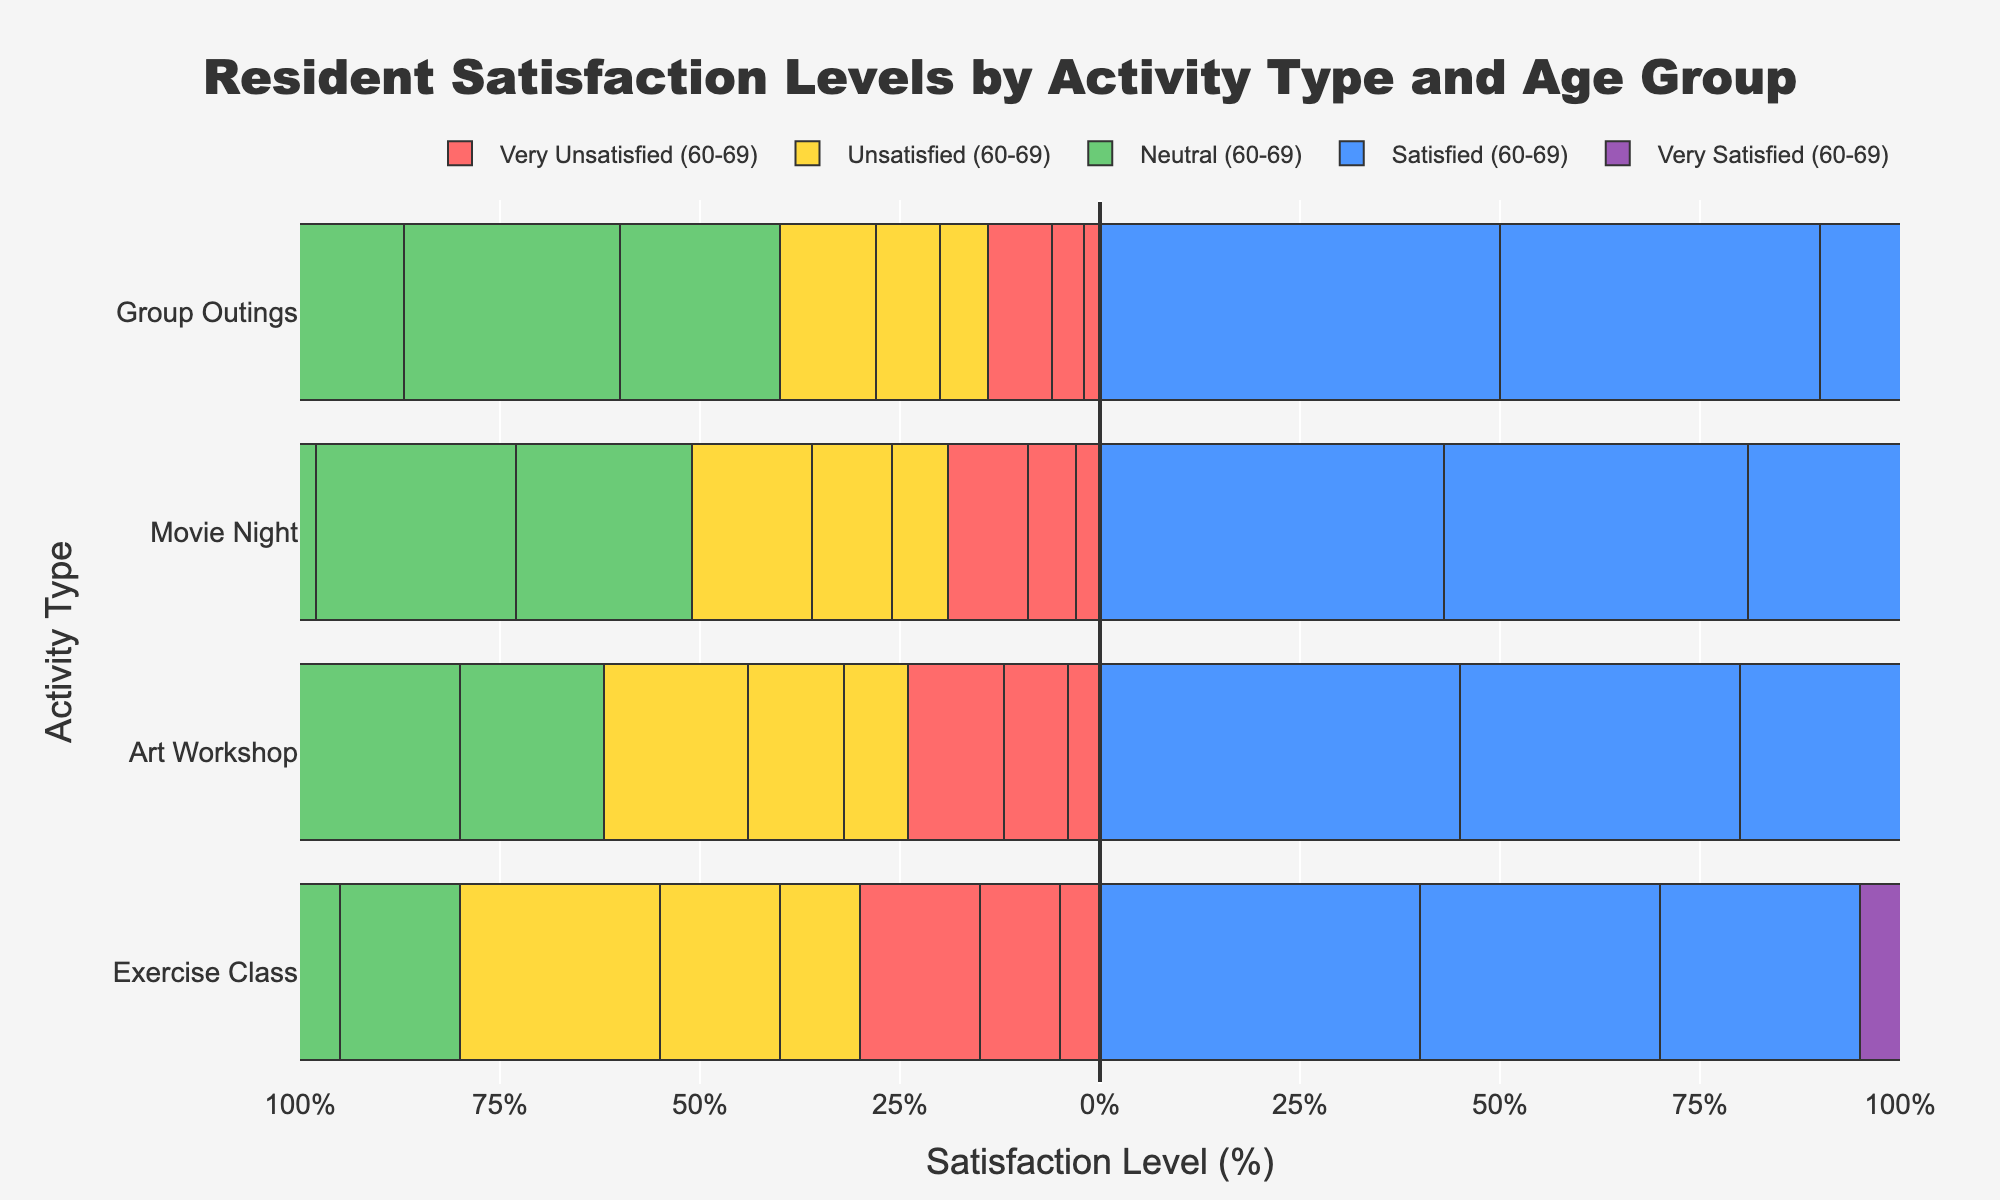What is the total percentage of residents aged 60-69 that are either satisfied or very satisfied with the Group Outings activity? First, look at the Group Outings activity for the 60-69 age group. The percentage of satisfied residents is 50%, and very satisfied residents is 22%. Adding these percentages together gives 50% + 22% = 72%.
Answer: 72% Which age group shows the highest level of satisfaction (satisfied + very satisfied) for the Movie Night activity? For the Movie Night activity, calculate the combined percentage of satisfied and very satisfied residents for each age group: 60-69 is 43% + 25% = 68%, 70-79 is 38% + 21% = 59%, and 80-89 is 32% + 15% = 47%. Therefore, the 60-69 group has the highest satisfaction level at 68%.
Answer: 60-69 What is the difference in the percentage of residents who are very unsatisfied with the Exercise Class activity between the age groups 60-69 and 80-89? For the Exercise Class activity, the very unsatisfied percentages are 5% for 60-69 and 15% for 80-89. The difference is 15% - 5% = 10%.
Answer: 10% How does the level of neutral satisfaction for the Art Workshop activity compare between the age groups 70-79 and 80-89? For the Art Workshop activity, the neutral percentages are 22% for 70-79 and 25% for 80-89. Therefore, 80-89 has a slightly higher neutral satisfaction level (25% compared to 22%).
Answer: 80-89 has a slightly higher neutral satisfaction Which activity shows the smallest percentage of very unsatisfied residents for the age group 70-79? Look at the very unsatisfied percentages for 70-79 across all activities: Exercise Class (10%), Art Workshop (8%), Movie Night (6%), Group Outings (4%). Group Outings has the smallest percentage at 4%.
Answer: Group Outings Which age group has the highest percentage of neutral responses for Group Outings? Compare the neutral responses for Group Outings across all age groups: 60-69 is 20%, 70-79 is 27%, and 80-89 is 30%. The highest percentage is for the 80-89 group at 30%.
Answer: 80-89 How does the percentage of very satisfied residents with the Exercise Class activity change from age group 60-69 to 80-89? For Exercise Class, the very satisfied percentages are: 60-69 is 30%, 70-79 is 25%, and 80-89 is 15%. From 60-69 to 80-89, the percentage decreases by 30% - 15% = 15%.
Answer: Decreases by 15% Which activity type for the age group 70-79 has the highest combined dissatisfied and very dissatisfied percentages? For 70-79, calculate combined dissatisfied and very dissatisfied for each activity: Exercise Class (15% + 10% = 25%), Art Workshop (12% + 8% = 20%), Movie Night (10% + 6% = 16%), Group Outings (8% + 4% = 12%). Exercise Class has the highest combined percentage at 25%.
Answer: Exercise Class What is the average neutral satisfaction level across all activities for the age group 60-69? Sum the neutral percentages for all activities for 60-69: 15% (Exercise Class) + 18% (Art Workshop) + 22% (Movie Night) + 20% (Group Outings) = 75%. Divide by the number of activities: 75% / 4 = 18.75%.
Answer: 18.75% Which age group exhibits the least variation in satisfaction levels (satisfied and very satisfied) for all activities? Calculate the range (difference between satisfied + very satisfied) for each age group across activities: 
- 60-69: Exercise Class (40% + 30% = 70%), Art Workshop (45% + 25% = 70%), Movie Night (43% + 25% = 68%), Group Outings (50% + 22% = 72%); range = 72 - 68 = 4%.
- 70-79: Exercise Class (30% + 25% = 55%), Art Workshop (35% + 23% = 58%), Movie Night (38% + 21% = 59%), Group Outings (40% + 21% = 61%); range = 61 - 55 = 6%.
- 80-89: Exercise Class (25% + 15% = 40%), Art Workshop (30% + 15% = 45%), Movie Night (32% + 15% = 47%), Group Outings (35% + 15% = 50%); range = 50 - 40 = 10%.
The age group 60-69 has the least variation (4%).
Answer: 60-69 